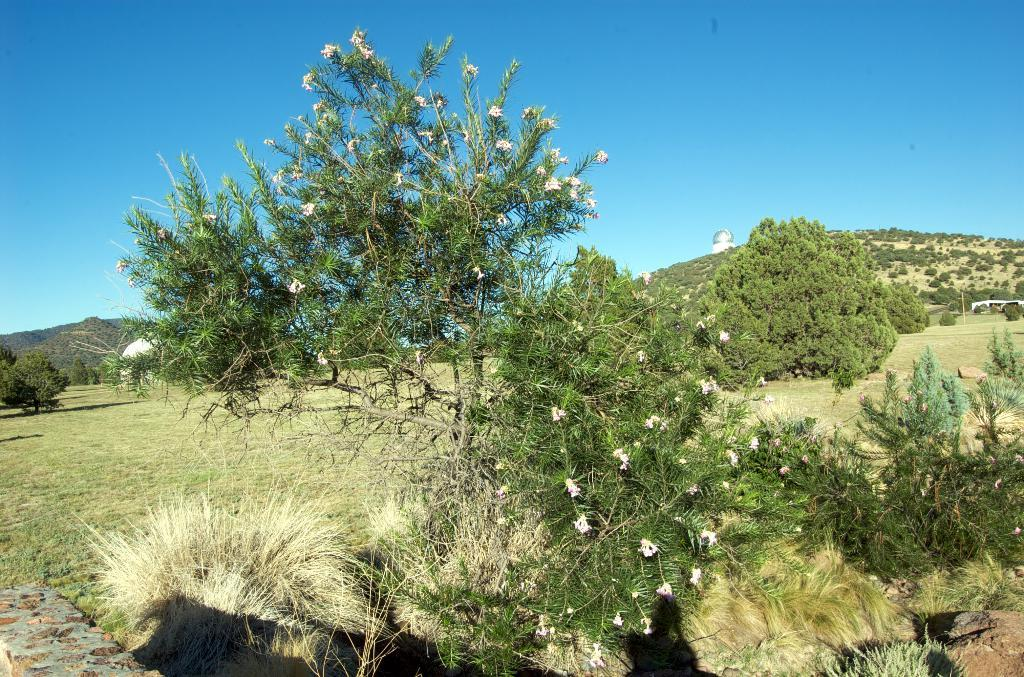What type of vegetation can be seen in the image? There are trees and plants in the image. What is the terrain like in the image? There is grassy land in the image. What can be seen in the background of the image? There is greenery on a mountain in the background of the image. What is visible at the top of the image? The sky is visible at the top of the image. How many caves can be seen in the image? There are no caves present in the image. What type of expansion is visible on the mountain in the image? There is no expansion visible on the mountain in the image; it is a natural landscape. 